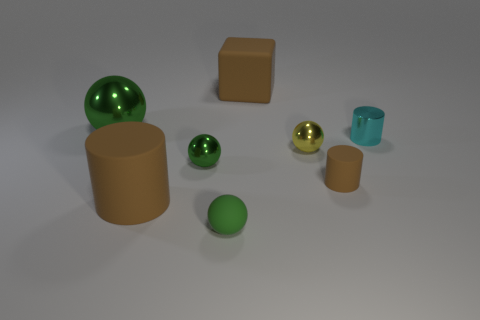Add 2 large matte things. How many objects exist? 10 Subtract all brown blocks. How many brown cylinders are left? 2 Subtract all small cylinders. How many cylinders are left? 1 Subtract all yellow spheres. How many spheres are left? 3 Subtract 1 cylinders. How many cylinders are left? 2 Subtract all blocks. How many objects are left? 7 Subtract all green spheres. Subtract all purple blocks. How many spheres are left? 1 Subtract all green rubber balls. Subtract all tiny yellow metal balls. How many objects are left? 6 Add 6 tiny brown rubber cylinders. How many tiny brown rubber cylinders are left? 7 Add 4 purple rubber objects. How many purple rubber objects exist? 4 